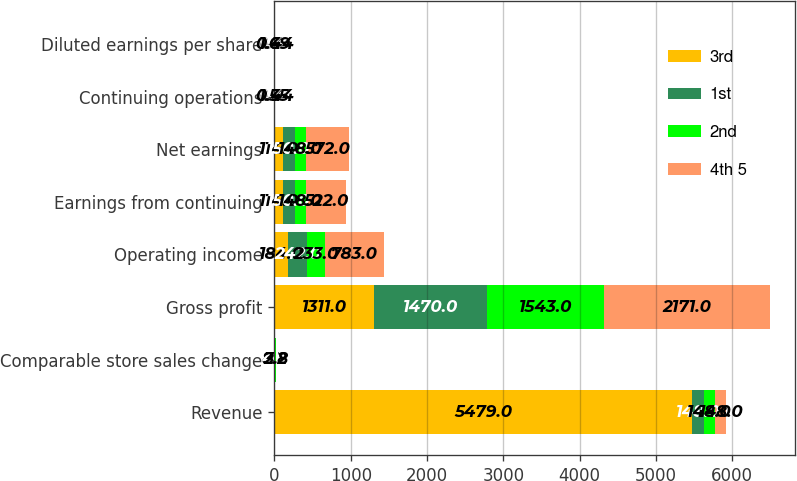Convert chart to OTSL. <chart><loc_0><loc_0><loc_500><loc_500><stacked_bar_chart><ecel><fcel>Revenue<fcel>Comparable store sales change<fcel>Gross profit<fcel>Operating income<fcel>Earnings from continuing<fcel>Net earnings<fcel>Continuing operations<fcel>Diluted earnings per share<nl><fcel>3rd<fcel>5479<fcel>8.3<fcel>1311<fcel>184<fcel>114<fcel>114<fcel>0.34<fcel>0.34<nl><fcel>1st<fcel>148<fcel>4.3<fcel>1470<fcel>242<fcel>150<fcel>150<fcel>0.45<fcel>0.45<nl><fcel>2nd<fcel>148<fcel>3.2<fcel>1543<fcel>233<fcel>148<fcel>148<fcel>0.44<fcel>0.44<nl><fcel>4th 5<fcel>148<fcel>2.8<fcel>2171<fcel>783<fcel>522<fcel>572<fcel>1.55<fcel>1.69<nl></chart> 